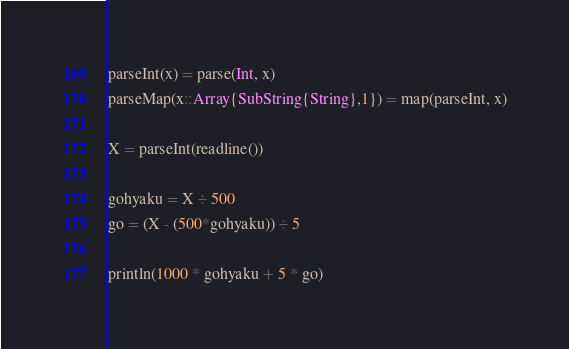<code> <loc_0><loc_0><loc_500><loc_500><_Julia_>parseInt(x) = parse(Int, x)
parseMap(x::Array{SubString{String},1}) = map(parseInt, x)

X = parseInt(readline())

gohyaku = X ÷ 500
go = (X - (500*gohyaku)) ÷ 5

println(1000 * gohyaku + 5 * go)</code> 